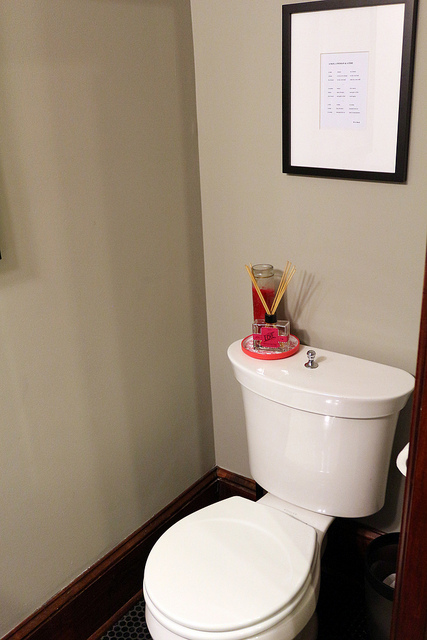What type of room does this appear to be, and can you infer its use? The image shows a bathroom, given the presence of the toilet. This room is typically used for personal hygiene activities. The clean and uncluttered state of the room suggests it is well-maintained, and the framed document on the wall adds a touch of personality or information for the user. 